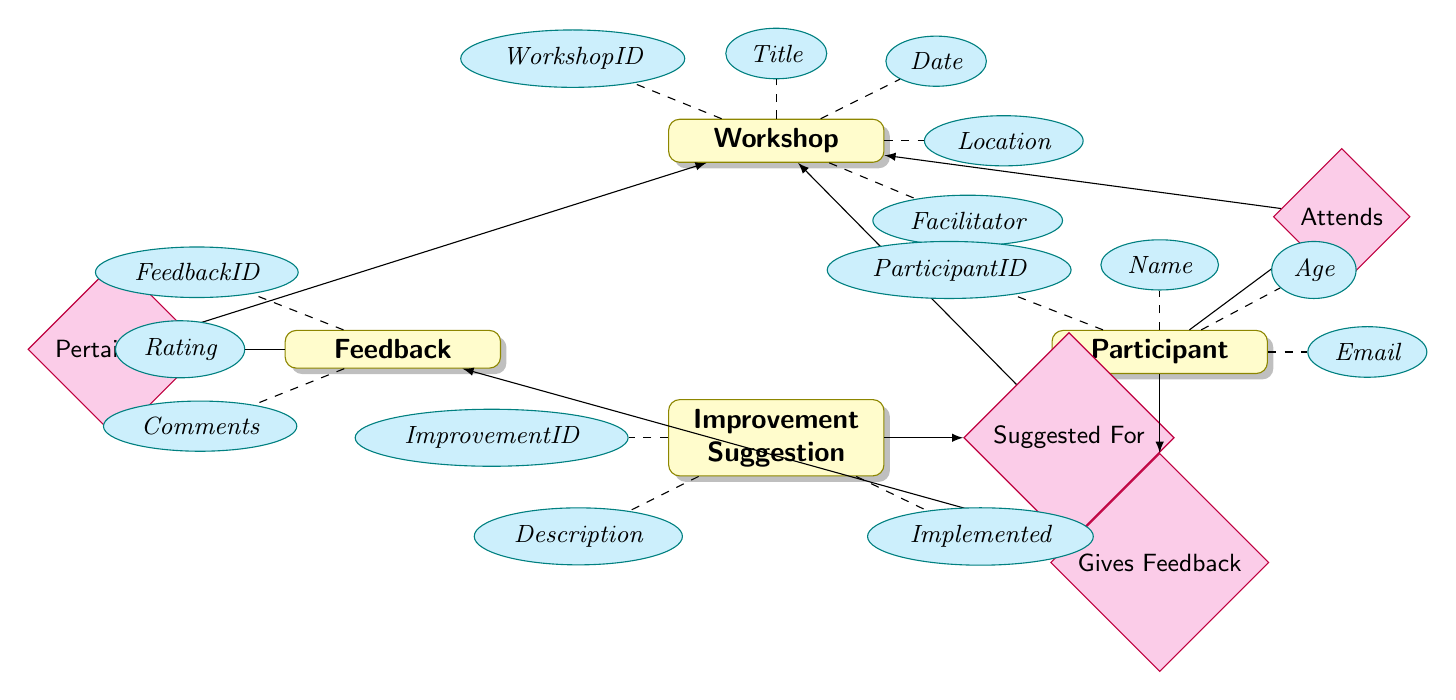What is the title of the Workshop entity? The Title attribute directly associated with the Workshop entity provides the name or title of the workshop being referenced.
Answer: Title How many attributes does the Participant entity have? The Participant entity has four attributes: ParticipantID, Name, Age, and Email. These attributes are listed under the Participant entity in the diagram.
Answer: 4 What relationship exists between Feedback and Workshop? The Feedback entity has a relationship labeled 'Pertains To' with the Workshop entity, indicating that feedback is linked to specific workshops.
Answer: Pertains To How many relationships are in the diagram? The diagram shows four relationships: Attends, Gives Feedback, Pertains To, and Suggested For, which connect different entities.
Answer: 4 What is the improvement suggestion's attribute for whether it has been implemented? The attribute associated with whether an Improvement Suggestion has been implemented is called Implemented, which indicates the status of the suggestion.
Answer: Implemented Which entity has the feedback rating attribute? The Feedback entity contains the Rating attribute, which is specifically related to the feedback provided by participants regarding their experience in workshops.
Answer: Feedback What is the Improvement ID? The ImprovementID is an attribute within the Improvement Suggestion entity that uniquely identifies each improvement suggestion made.
Answer: ImprovementID Who gives feedback in this diagram? The Participant entity is responsible for providing feedback, as shown by the Gives Feedback relationship connecting the Participant to the Feedback entity.
Answer: Participant What does the relationship 'Attends' indicate? The relationship 'Attends' indicates that a Participant attends a specific Workshop, showing the participation of individuals in these events.
Answer: Attends 